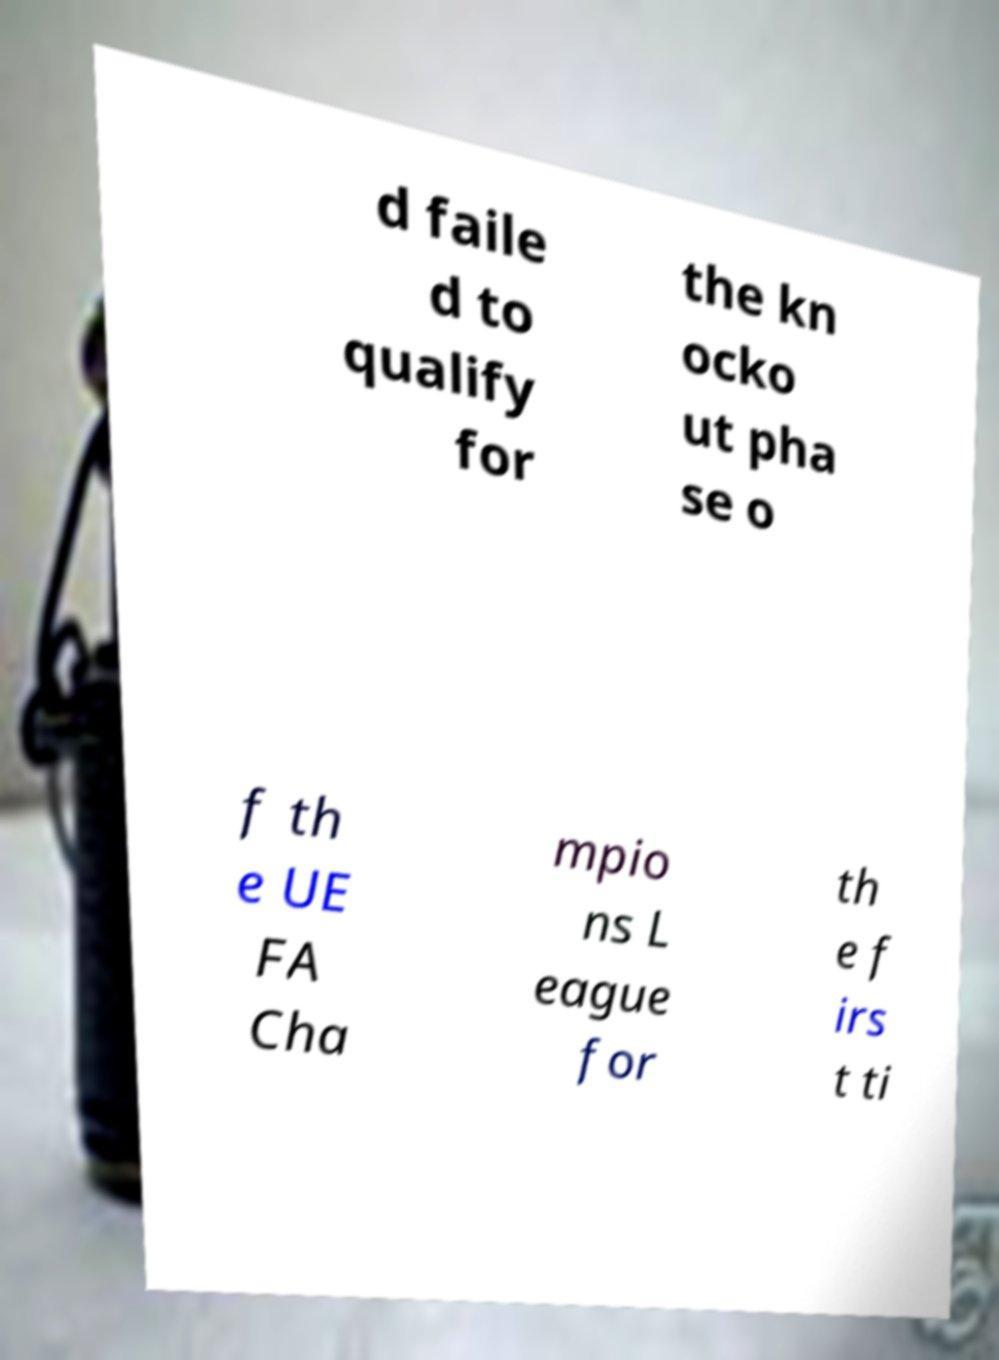Can you read and provide the text displayed in the image?This photo seems to have some interesting text. Can you extract and type it out for me? d faile d to qualify for the kn ocko ut pha se o f th e UE FA Cha mpio ns L eague for th e f irs t ti 